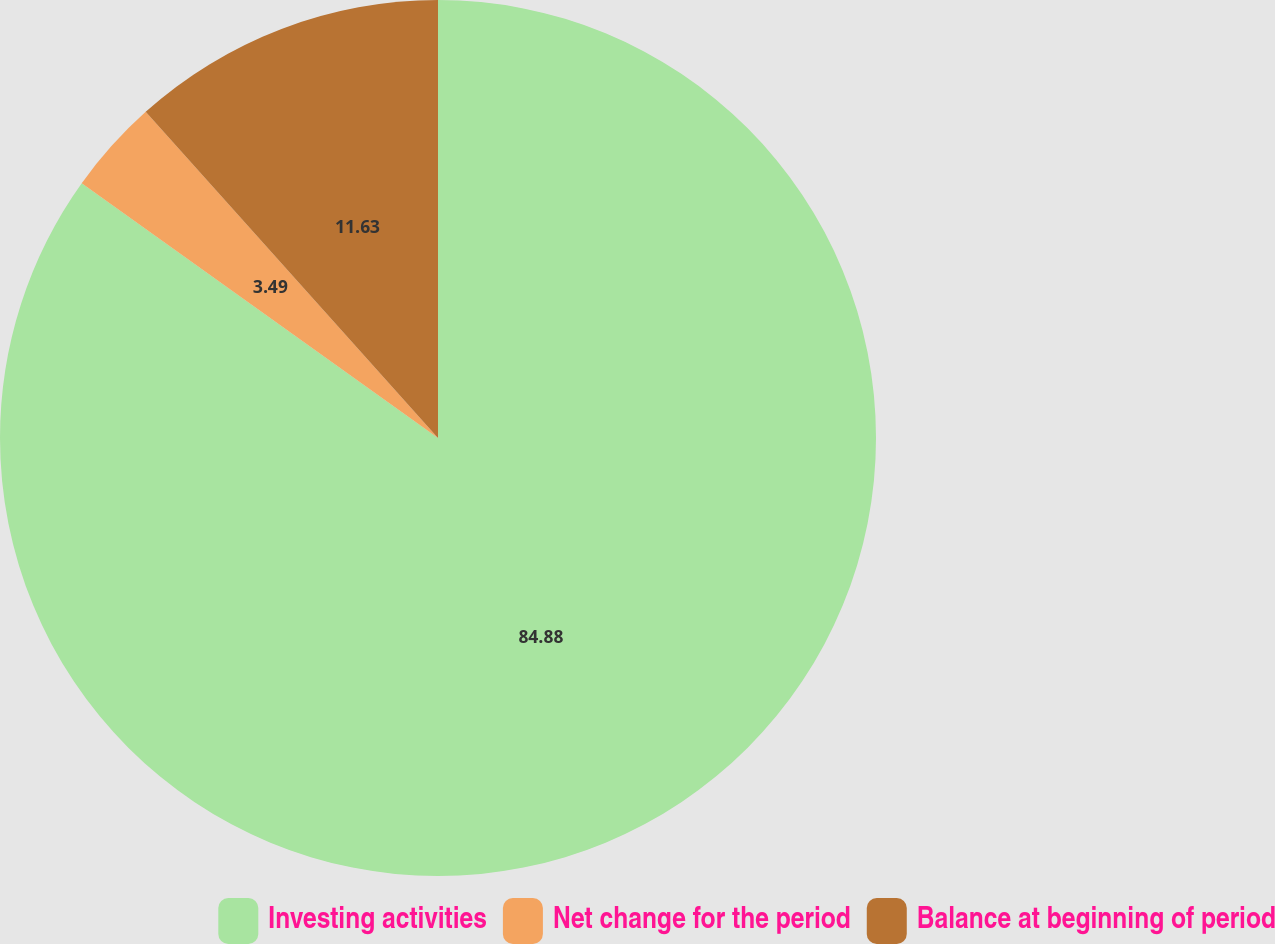<chart> <loc_0><loc_0><loc_500><loc_500><pie_chart><fcel>Investing activities<fcel>Net change for the period<fcel>Balance at beginning of period<nl><fcel>84.88%<fcel>3.49%<fcel>11.63%<nl></chart> 